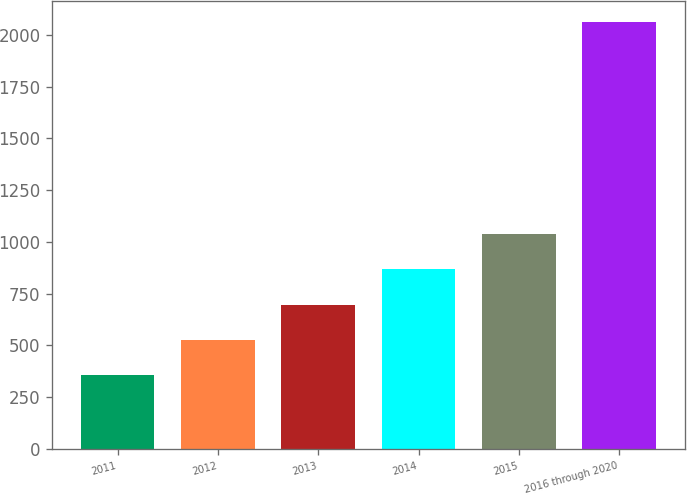Convert chart to OTSL. <chart><loc_0><loc_0><loc_500><loc_500><bar_chart><fcel>2011<fcel>2012<fcel>2013<fcel>2014<fcel>2015<fcel>2016 through 2020<nl><fcel>355<fcel>525.6<fcel>696.2<fcel>866.8<fcel>1037.4<fcel>2061<nl></chart> 